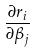<formula> <loc_0><loc_0><loc_500><loc_500>\frac { \partial r _ { i } } { \partial \beta _ { j } }</formula> 